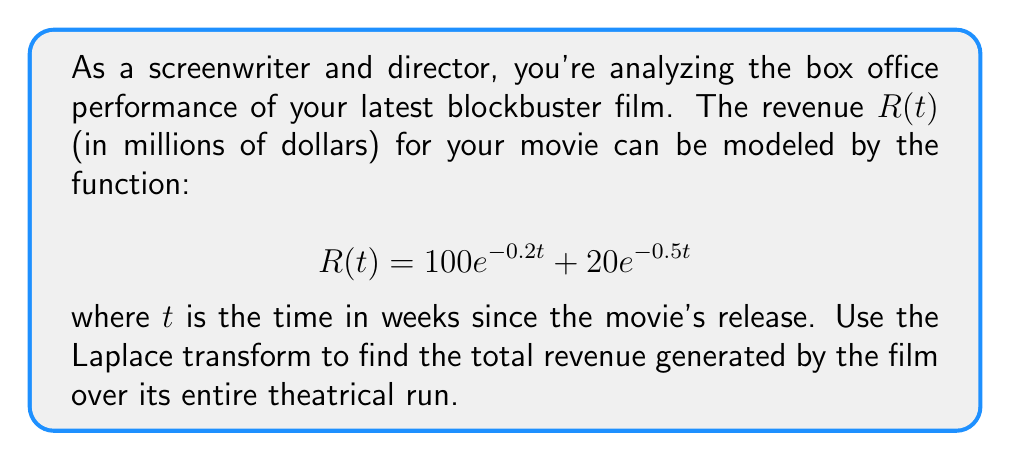Provide a solution to this math problem. To solve this problem, we'll use the Laplace transform and its properties. Let's break it down step-by-step:

1) The Laplace transform of $R(t)$ is denoted as $\mathcal{L}\{R(t)\} = R(s)$. We need to find $R(s)$.

2) Using the linearity property of the Laplace transform:
   $$R(s) = \mathcal{L}\{100e^{-0.2t}\} + \mathcal{L}\{20e^{-0.5t}\}$$

3) Recall the Laplace transform of an exponential function:
   $$\mathcal{L}\{e^{at}\} = \frac{1}{s-a}$$

4) Applying this to our function:
   $$R(s) = 100 \cdot \frac{1}{s+0.2} + 20 \cdot \frac{1}{s+0.5}$$

5) To find the total revenue, we need to evaluate $R(s)$ at $s=0$. This is because:
   $$\int_0^{\infty} R(t) dt = \lim_{s \to 0} R(s)$$

6) Evaluating $R(s)$ at $s=0$:
   $$R(0) = 100 \cdot \frac{1}{0+0.2} + 20 \cdot \frac{1}{0+0.5}$$

7) Simplifying:
   $$R(0) = 100 \cdot 5 + 20 \cdot 2 = 500 + 40 = 540$$

Therefore, the total revenue generated by the film over its entire theatrical run is $540 million.
Answer: $540 million 